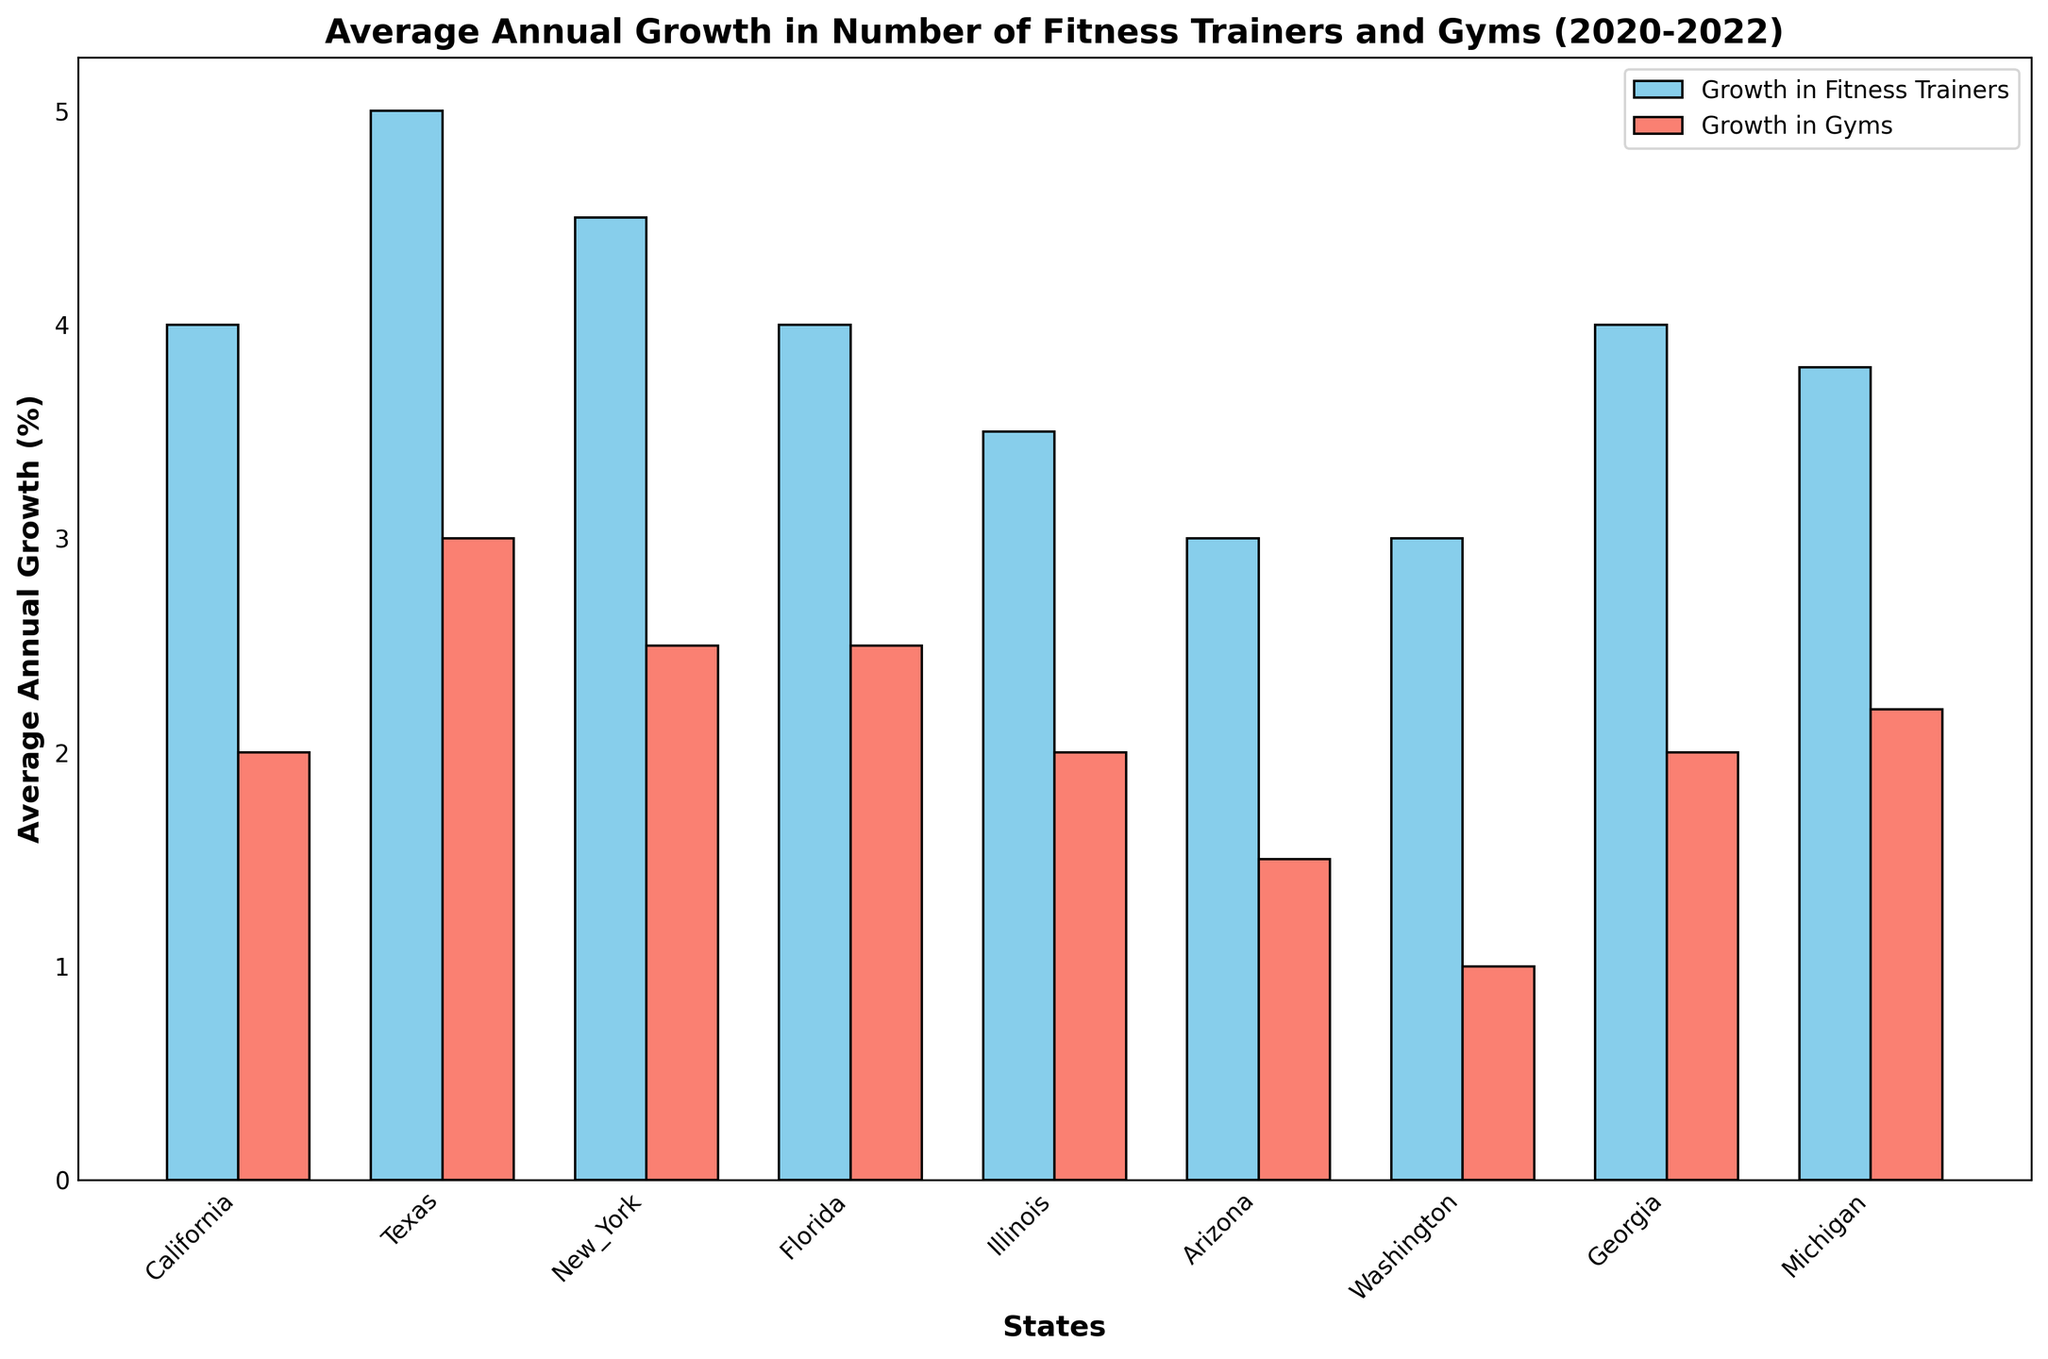What state has the highest average annual growth in the number of fitness trainers? Identify the bar representing growth in fitness trainers for each state. The highest bar corresponds to California.
Answer: California Which state shows a higher average annual growth in gyms, Texas or Florida? Compare the height of the bars representing growth in gyms for Texas and Florida. The bar for Florida is higher.
Answer: Florida How does the average annual growth in fitness trainers in New York compare to that in Michigan? Compare the height of the bars representing growth in fitness trainers for New York and Michigan. The bar for New York is slightly taller.
Answer: New York What is the difference in average annual growth in gyms between California and Arizona? Compare the height of the bars representing growth in gyms for California and Arizona. Subtract the height of the Arizona bar from the California bar.
Answer: 1 Which has a greater average annual growth, fitness trainers in Georgia or gyms in Washington? Compare the height of the bars representing growth in fitness trainers in Georgia and growth in gyms in Washington. The bar for fitness trainers in Georgia is taller.
Answer: Fitness trainers in Georgia What is the combined average annual growth in fitness trainers for Illinois and Arizona? Add the height of the bars representing growth in fitness trainers for Illinois and Arizona.
Answer: 7.5 Does Washington show a greater average growth in gyms or fitness trainers? Compare the height of the bars representing growth in gyms and fitness trainers for Washington. The bar for fitness trainers is taller.
Answer: Fitness trainers Which state's average annual growth in fitness trainers is closest to 4%? Find the bar heights closest to 4% for fitness trainers. Texas, Georgia, and Arizona all have bars at 4%.
Answer: Texas, Georgia, Arizona How does California's average annual growth in fitness trainers compare to the sum of New York and Michigan's average annual growth? Compare the height of the bar for fitness trainers in California to the combined height of the bars for New York and Michigan. California is slightly higher.
Answer: California What is the average annual growth rate difference between fitness trainers and gyms for Illinois? Identify the bars representing growth for fitness trainers and gyms in Illinois, then subtract the height of the bar for gyms from that of fitness trainers.
Answer: 1.5 